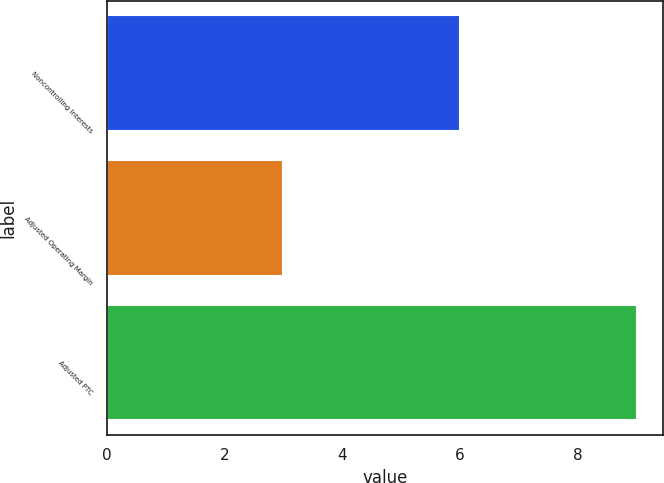Convert chart. <chart><loc_0><loc_0><loc_500><loc_500><bar_chart><fcel>Noncontrolling Interests<fcel>Adjusted Operating Margin<fcel>Adjusted PTC<nl><fcel>6<fcel>3<fcel>9<nl></chart> 